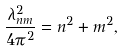<formula> <loc_0><loc_0><loc_500><loc_500>\frac { \lambda _ { n m } ^ { 2 } } { 4 \pi ^ { 2 } } = n ^ { 2 } + m ^ { 2 } ,</formula> 